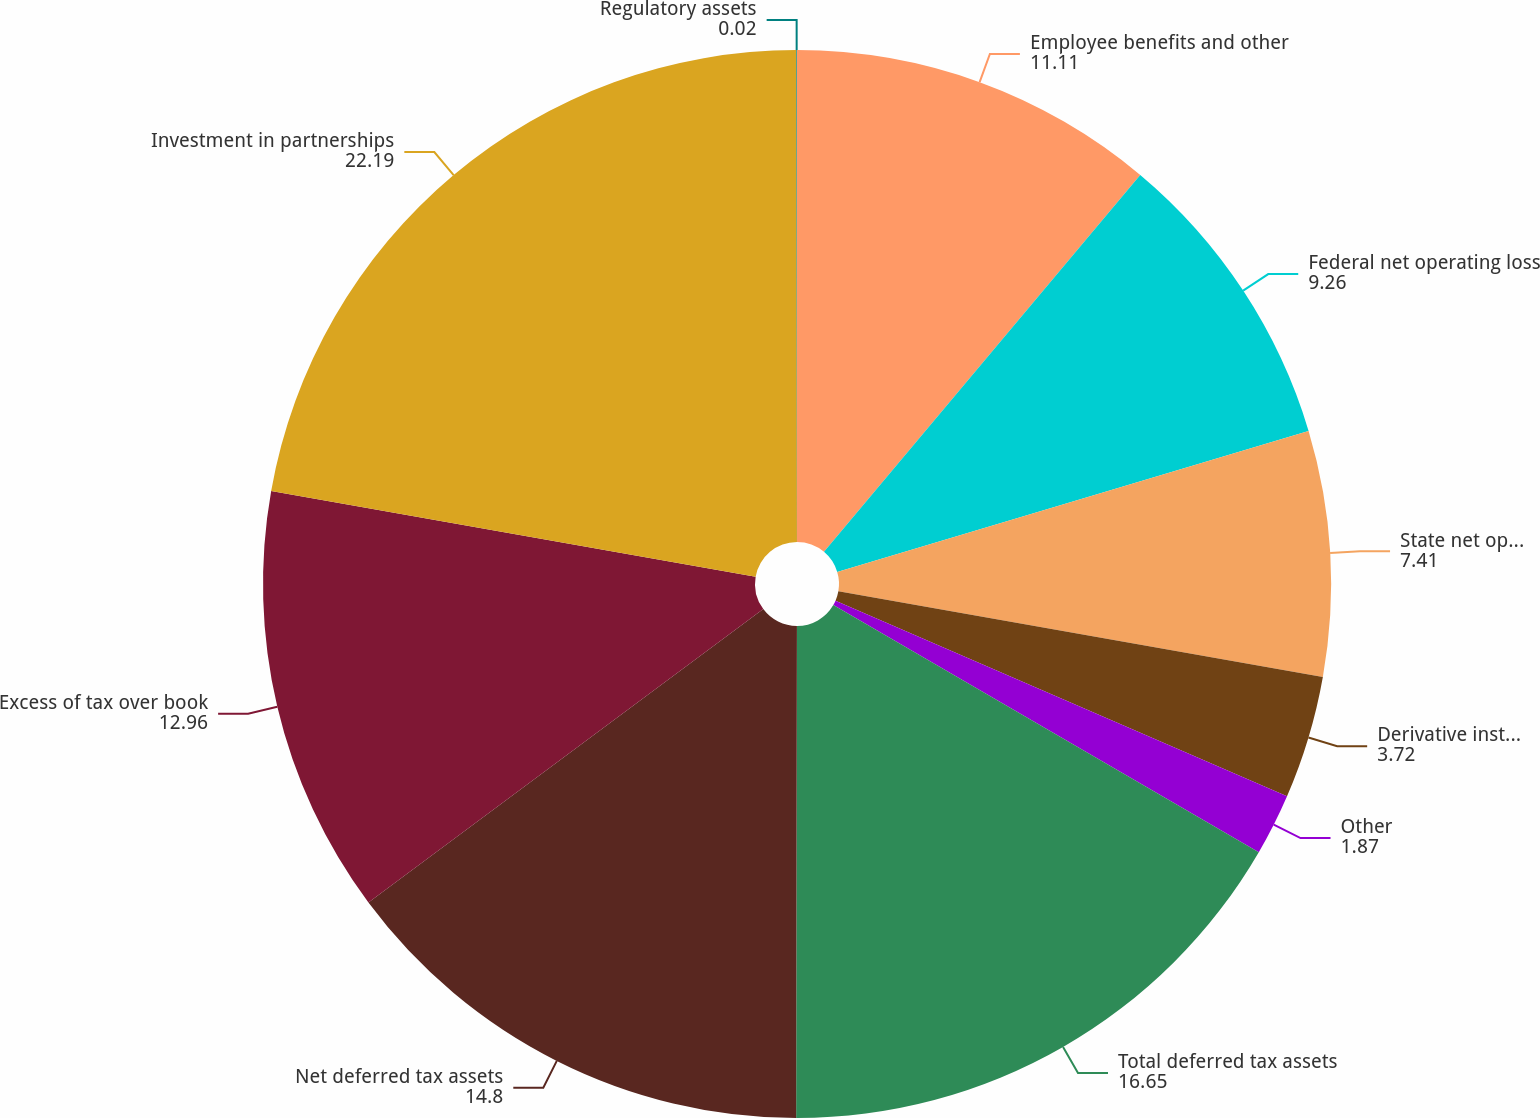Convert chart to OTSL. <chart><loc_0><loc_0><loc_500><loc_500><pie_chart><fcel>Employee benefits and other<fcel>Federal net operating loss<fcel>State net operating loss and<fcel>Derivative instruments<fcel>Other<fcel>Total deferred tax assets<fcel>Net deferred tax assets<fcel>Excess of tax over book<fcel>Investment in partnerships<fcel>Regulatory assets<nl><fcel>11.11%<fcel>9.26%<fcel>7.41%<fcel>3.72%<fcel>1.87%<fcel>16.65%<fcel>14.8%<fcel>12.96%<fcel>22.19%<fcel>0.02%<nl></chart> 